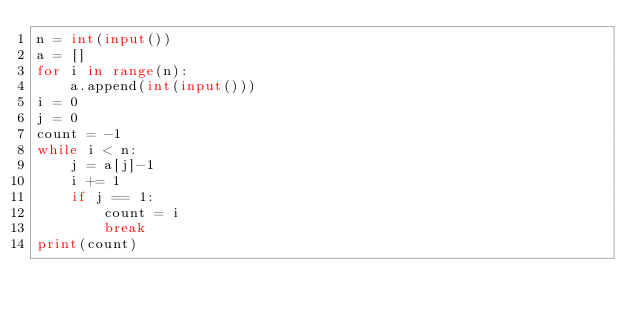Convert code to text. <code><loc_0><loc_0><loc_500><loc_500><_Python_>n = int(input())
a = []
for i in range(n):
    a.append(int(input()))
i = 0
j = 0
count = -1
while i < n:
    j = a[j]-1
    i += 1
    if j == 1:
        count = i
        break
print(count)</code> 